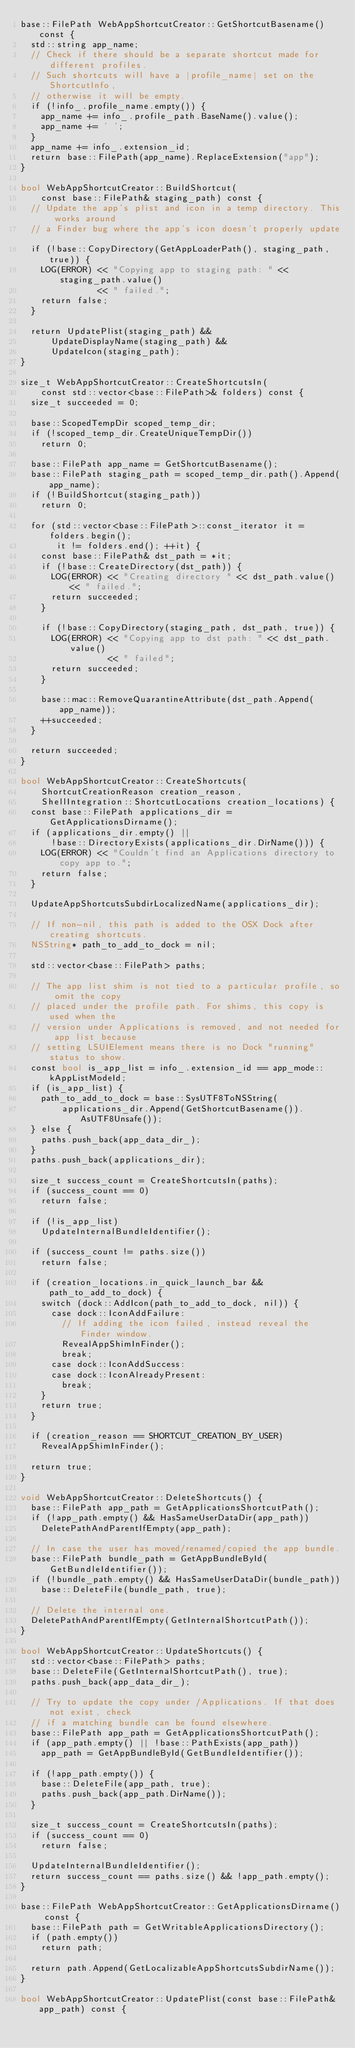Convert code to text. <code><loc_0><loc_0><loc_500><loc_500><_ObjectiveC_>base::FilePath WebAppShortcutCreator::GetShortcutBasename() const {
  std::string app_name;
  // Check if there should be a separate shortcut made for different profiles.
  // Such shortcuts will have a |profile_name| set on the ShortcutInfo,
  // otherwise it will be empty.
  if (!info_.profile_name.empty()) {
    app_name += info_.profile_path.BaseName().value();
    app_name += ' ';
  }
  app_name += info_.extension_id;
  return base::FilePath(app_name).ReplaceExtension("app");
}

bool WebAppShortcutCreator::BuildShortcut(
    const base::FilePath& staging_path) const {
  // Update the app's plist and icon in a temp directory. This works around
  // a Finder bug where the app's icon doesn't properly update.
  if (!base::CopyDirectory(GetAppLoaderPath(), staging_path, true)) {
    LOG(ERROR) << "Copying app to staging path: " << staging_path.value()
               << " failed.";
    return false;
  }

  return UpdatePlist(staging_path) &&
      UpdateDisplayName(staging_path) &&
      UpdateIcon(staging_path);
}

size_t WebAppShortcutCreator::CreateShortcutsIn(
    const std::vector<base::FilePath>& folders) const {
  size_t succeeded = 0;

  base::ScopedTempDir scoped_temp_dir;
  if (!scoped_temp_dir.CreateUniqueTempDir())
    return 0;

  base::FilePath app_name = GetShortcutBasename();
  base::FilePath staging_path = scoped_temp_dir.path().Append(app_name);
  if (!BuildShortcut(staging_path))
    return 0;

  for (std::vector<base::FilePath>::const_iterator it = folders.begin();
       it != folders.end(); ++it) {
    const base::FilePath& dst_path = *it;
    if (!base::CreateDirectory(dst_path)) {
      LOG(ERROR) << "Creating directory " << dst_path.value() << " failed.";
      return succeeded;
    }

    if (!base::CopyDirectory(staging_path, dst_path, true)) {
      LOG(ERROR) << "Copying app to dst path: " << dst_path.value()
                 << " failed";
      return succeeded;
    }

    base::mac::RemoveQuarantineAttribute(dst_path.Append(app_name));
    ++succeeded;
  }

  return succeeded;
}

bool WebAppShortcutCreator::CreateShortcuts(
    ShortcutCreationReason creation_reason,
    ShellIntegration::ShortcutLocations creation_locations) {
  const base::FilePath applications_dir = GetApplicationsDirname();
  if (applications_dir.empty() ||
      !base::DirectoryExists(applications_dir.DirName())) {
    LOG(ERROR) << "Couldn't find an Applications directory to copy app to.";
    return false;
  }

  UpdateAppShortcutsSubdirLocalizedName(applications_dir);

  // If non-nil, this path is added to the OSX Dock after creating shortcuts.
  NSString* path_to_add_to_dock = nil;

  std::vector<base::FilePath> paths;

  // The app list shim is not tied to a particular profile, so omit the copy
  // placed under the profile path. For shims, this copy is used when the
  // version under Applications is removed, and not needed for app list because
  // setting LSUIElement means there is no Dock "running" status to show.
  const bool is_app_list = info_.extension_id == app_mode::kAppListModeId;
  if (is_app_list) {
    path_to_add_to_dock = base::SysUTF8ToNSString(
        applications_dir.Append(GetShortcutBasename()).AsUTF8Unsafe());
  } else {
    paths.push_back(app_data_dir_);
  }
  paths.push_back(applications_dir);

  size_t success_count = CreateShortcutsIn(paths);
  if (success_count == 0)
    return false;

  if (!is_app_list)
    UpdateInternalBundleIdentifier();

  if (success_count != paths.size())
    return false;

  if (creation_locations.in_quick_launch_bar && path_to_add_to_dock) {
    switch (dock::AddIcon(path_to_add_to_dock, nil)) {
      case dock::IconAddFailure:
        // If adding the icon failed, instead reveal the Finder window.
        RevealAppShimInFinder();
        break;
      case dock::IconAddSuccess:
      case dock::IconAlreadyPresent:
        break;
    }
    return true;
  }

  if (creation_reason == SHORTCUT_CREATION_BY_USER)
    RevealAppShimInFinder();

  return true;
}

void WebAppShortcutCreator::DeleteShortcuts() {
  base::FilePath app_path = GetApplicationsShortcutPath();
  if (!app_path.empty() && HasSameUserDataDir(app_path))
    DeletePathAndParentIfEmpty(app_path);

  // In case the user has moved/renamed/copied the app bundle.
  base::FilePath bundle_path = GetAppBundleById(GetBundleIdentifier());
  if (!bundle_path.empty() && HasSameUserDataDir(bundle_path))
    base::DeleteFile(bundle_path, true);

  // Delete the internal one.
  DeletePathAndParentIfEmpty(GetInternalShortcutPath());
}

bool WebAppShortcutCreator::UpdateShortcuts() {
  std::vector<base::FilePath> paths;
  base::DeleteFile(GetInternalShortcutPath(), true);
  paths.push_back(app_data_dir_);

  // Try to update the copy under /Applications. If that does not exist, check
  // if a matching bundle can be found elsewhere.
  base::FilePath app_path = GetApplicationsShortcutPath();
  if (app_path.empty() || !base::PathExists(app_path))
    app_path = GetAppBundleById(GetBundleIdentifier());

  if (!app_path.empty()) {
    base::DeleteFile(app_path, true);
    paths.push_back(app_path.DirName());
  }

  size_t success_count = CreateShortcutsIn(paths);
  if (success_count == 0)
    return false;

  UpdateInternalBundleIdentifier();
  return success_count == paths.size() && !app_path.empty();
}

base::FilePath WebAppShortcutCreator::GetApplicationsDirname() const {
  base::FilePath path = GetWritableApplicationsDirectory();
  if (path.empty())
    return path;

  return path.Append(GetLocalizableAppShortcutsSubdirName());
}

bool WebAppShortcutCreator::UpdatePlist(const base::FilePath& app_path) const {</code> 